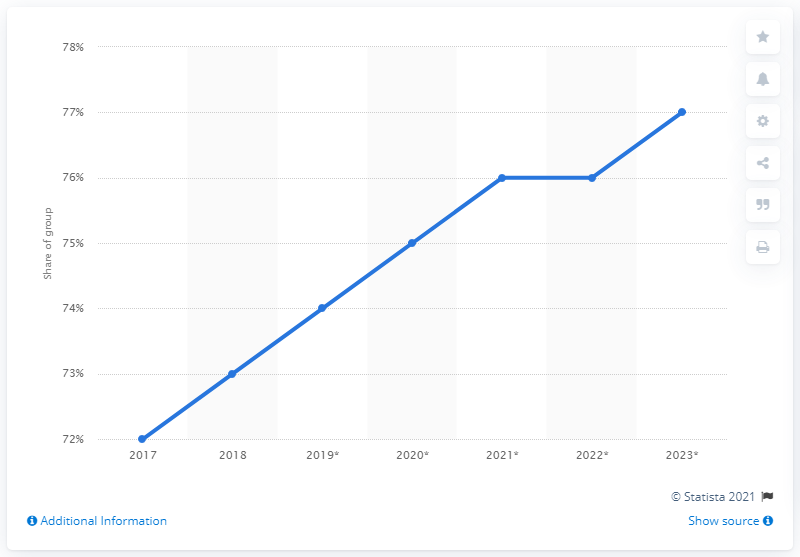Identify some key points in this picture. In 2019, it is projected that 74% of Malaysians will use social media. 